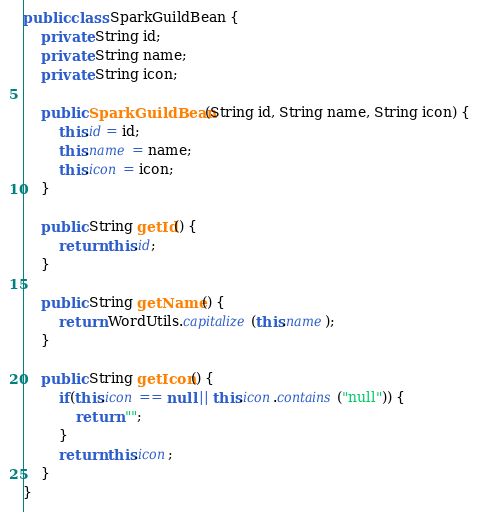<code> <loc_0><loc_0><loc_500><loc_500><_Java_>
public class SparkGuildBean {
	private String id;
	private String name;
	private String icon;
	
	public SparkGuildBean(String id, String name, String icon) {
		this.id = id;
		this.name = name;
		this.icon = icon;
	}
	
	public String getId() {
		return this.id;
	}
	
	public String getName() {
		return WordUtils.capitalize(this.name);
	}
	
	public String getIcon() {
		if(this.icon == null || this.icon.contains("null")) {
			return "";
		}
		return this.icon;
	}
}
</code> 